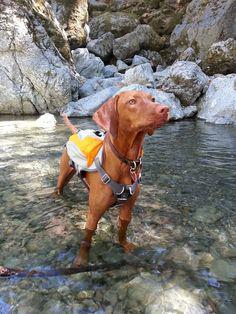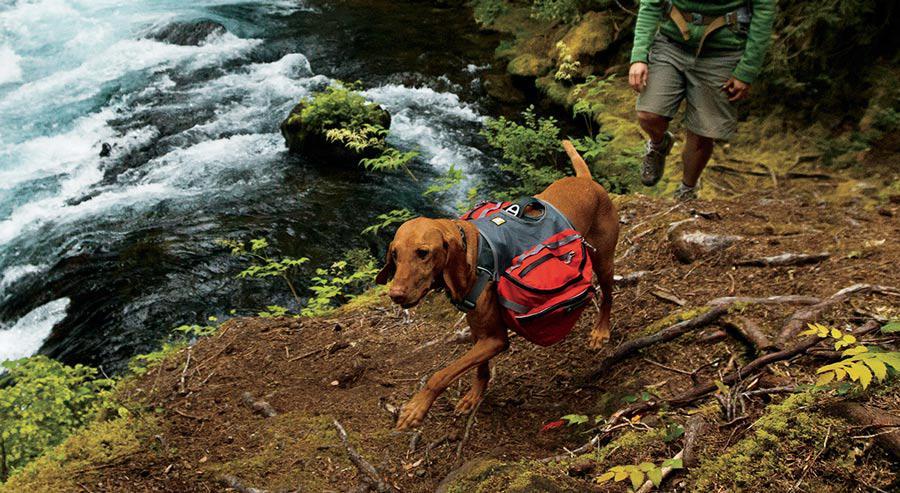The first image is the image on the left, the second image is the image on the right. Analyze the images presented: Is the assertion "In one image, a red-orange dog in a collar with a leash attached stands on a high rock perch gazing." valid? Answer yes or no. No. The first image is the image on the left, the second image is the image on the right. For the images shown, is this caption "There is three dogs." true? Answer yes or no. No. 